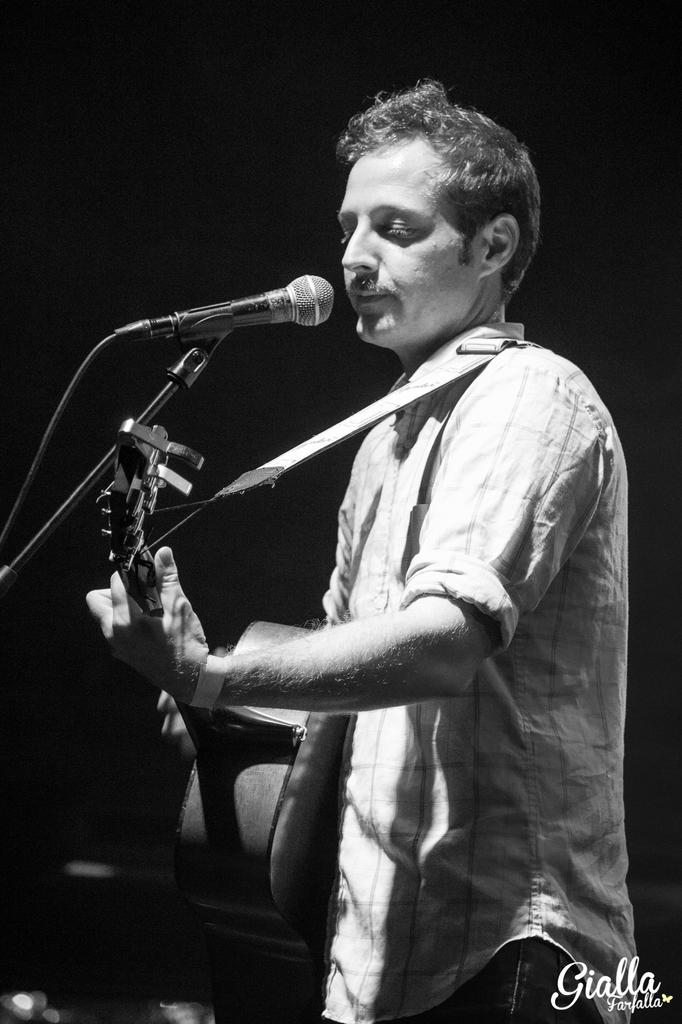What is the main subject of the image? There is a person in the image. Where is the person located in the image? The person is standing at the right side of the image. What is the person holding in the image? The person is holding a guitar. What is the color of the background in the image? The background of the image is black in color. What type of root can be seen growing from the ground in the image? There is no root or ground visible in the image; it features a person standing with a guitar against a black background. 